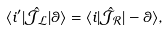Convert formula to latex. <formula><loc_0><loc_0><loc_500><loc_500>\langle i ^ { \prime } | \hat { \mathcal { J _ { L } } } | \theta \rangle = \langle i | \hat { \mathcal { J _ { R } } } | - \theta \rangle ,</formula> 